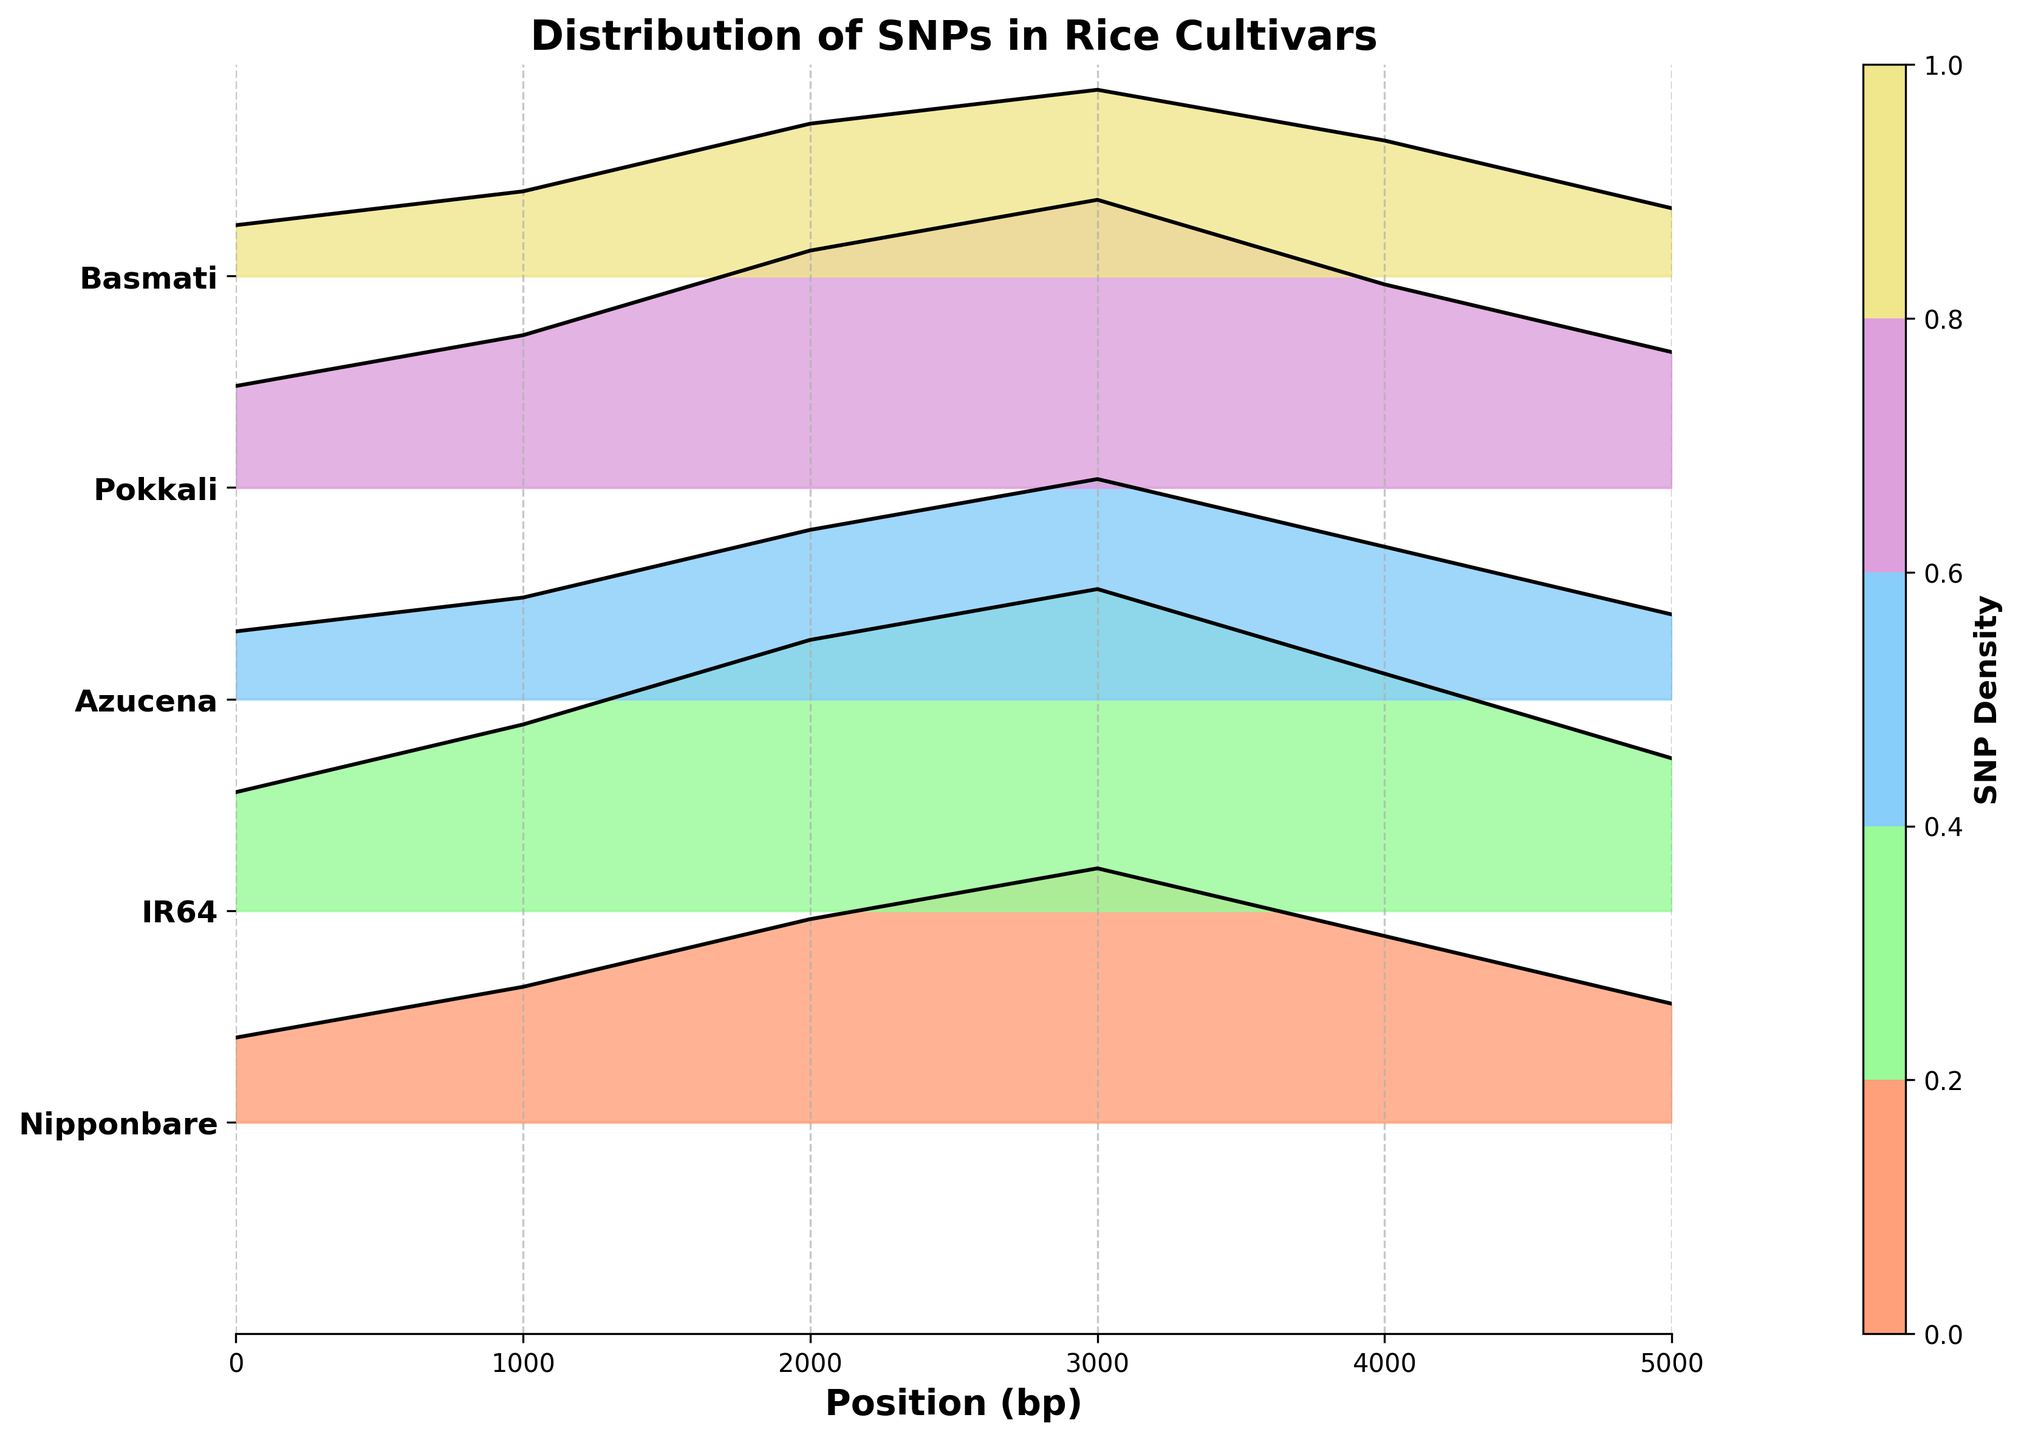Which cultivar shows the highest SNP density at position 3000 bp? At position 3000 bp, observe the height of the plots for each cultivar. The highest plot corresponds to the highest SNP density. IR64 has the tallest plot at this position.
Answer: IR64 What is the SNP density of the Basmati cultivar at position 1000 bp? Locate the Basmati line at position 1000 bp. The height indicates the SNP density. The line reaches a value of 0.5.
Answer: 0.5 Which cultivar has the lowest overall SNP density? Compare the heights of the plots across all positions for each cultivar, looking for the cultivar that generally stays lower than others. Basmati consistently has lower heights.
Answer: Basmati How does the SNP density of Azucena compare to Pokkali at position 4000 bp? Locate both Azucena and Pokkali lines at position 4000 bp. Compare their heights to determine which is higher. Pokkali's plot is taller than Azucena's at this position.
Answer: Pokkali's SNP density is higher Which cultivar has a peak SNP density greater than 1 at position 2000 bp? Check each cultivar's height at position 2000 bp to see if it exceeds 1. Both IR64 and Pokkali exceed this value.
Answer: IR64 and Pokkali What is the trend of SNP density across positions for IR64 from 0 to 5000 bp? Observe the plot for IR64 from position 0 to 5000 bp, noting how SNP density changes. IR64 starts at 0.7, increases to a peak of 1.9 at 3000 bp, then gradually decreases.
Answer: Increases to peak at 3000 bp, then decreases Which cultivars have a SNP density less than 1 at position 2000 bp? Check the height of each cultivar's plot at position 2000 bp and determine which ones are below 1. Basmati and Azucena are below this level.
Answer: Basmati and Azucena At which position does Pokkali show its highest SNP density? Observe the heights of Pokkali's plot across all positions. The highest point is at position 3000 bp with a density of 1.7.
Answer: 3000 bp How does the SNP density of Nipponbare change from position 0 to 3000 bp? Trace the plot for Nipponbare from position 0 to 3000 bp and note the changes in height. Nipponbare's SNP density increases steadily from 0.5 to 1.5 at 3000 bp.
Answer: Increases steadily Which cultivar's SNP density plot shows the least variation? Examine the fluctuation in plot heights for each cultivar. Azucena's plot has the smallest variations across positions.
Answer: Azucena 